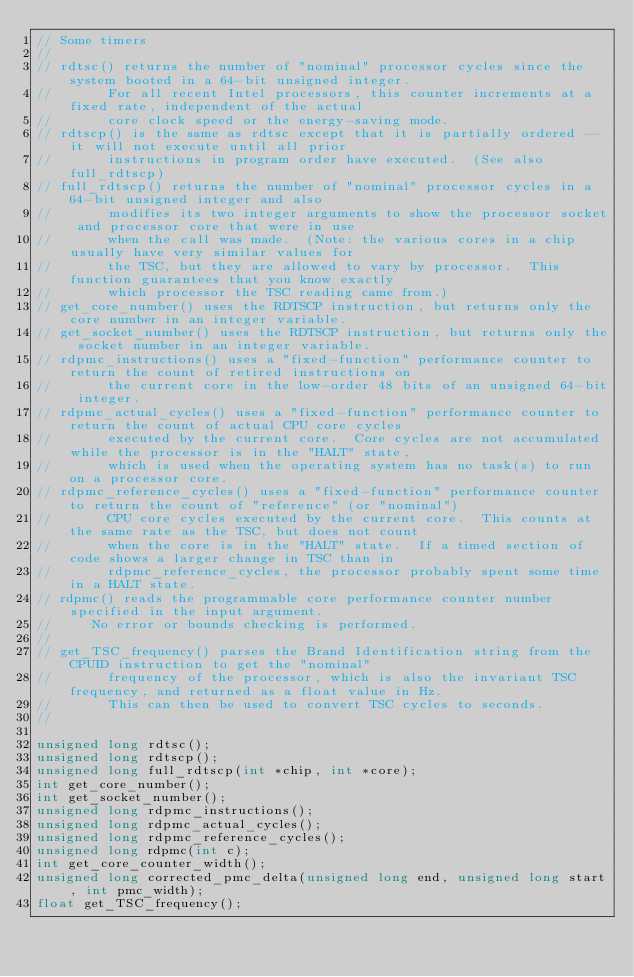<code> <loc_0><loc_0><loc_500><loc_500><_C_>// Some timers
//
// rdtsc() returns the number of "nominal" processor cycles since the system booted in a 64-bit unsigned integer.
//       For all recent Intel processors, this counter increments at a fixed rate, independent of the actual
//       core clock speed or the energy-saving mode.
// rdtscp() is the same as rdtsc except that it is partially ordered -- it will not execute until all prior
//       instructions in program order have executed.  (See also full_rdtscp)
// full_rdtscp() returns the number of "nominal" processor cycles in a 64-bit unsigned integer and also 
//       modifies its two integer arguments to show the processor socket and processor core that were in use
//       when the call was made.  (Note: the various cores in a chip usually have very similar values for 
//       the TSC, but they are allowed to vary by processor.  This function guarantees that you know exactly
//       which processor the TSC reading came from.)
// get_core_number() uses the RDTSCP instruction, but returns only the core number in an integer variable.
// get_socket_number() uses the RDTSCP instruction, but returns only the socket number in an integer variable.
// rdpmc_instructions() uses a "fixed-function" performance counter to return the count of retired instructions on
//       the current core in the low-order 48 bits of an unsigned 64-bit integer.
// rdpmc_actual_cycles() uses a "fixed-function" performance counter to return the count of actual CPU core cycles
//       executed by the current core.  Core cycles are not accumulated while the processor is in the "HALT" state,
//       which is used when the operating system has no task(s) to run on a processor core.
// rdpmc_reference_cycles() uses a "fixed-function" performance counter to return the count of "reference" (or "nominal")
//       CPU core cycles executed by the current core.  This counts at the same rate as the TSC, but does not count
//       when the core is in the "HALT" state.  If a timed section of code shows a larger change in TSC than in
//       rdpmc_reference_cycles, the processor probably spent some time in a HALT state.
// rdpmc() reads the programmable core performance counter number specified in the input argument.
//		 No error or bounds checking is performed.
//
// get_TSC_frequency() parses the Brand Identification string from the CPUID instruction to get the "nominal"
//       frequency of the processor, which is also the invariant TSC frequency, and returned as a float value in Hz.
//       This can then be used to convert TSC cycles to seconds.
//

unsigned long rdtsc();
unsigned long rdtscp();
unsigned long full_rdtscp(int *chip, int *core);
int get_core_number();
int get_socket_number();
unsigned long rdpmc_instructions();
unsigned long rdpmc_actual_cycles();
unsigned long rdpmc_reference_cycles();
unsigned long rdpmc(int c);
int get_core_counter_width();
unsigned long corrected_pmc_delta(unsigned long end, unsigned long start, int pmc_width);
float get_TSC_frequency();
</code> 